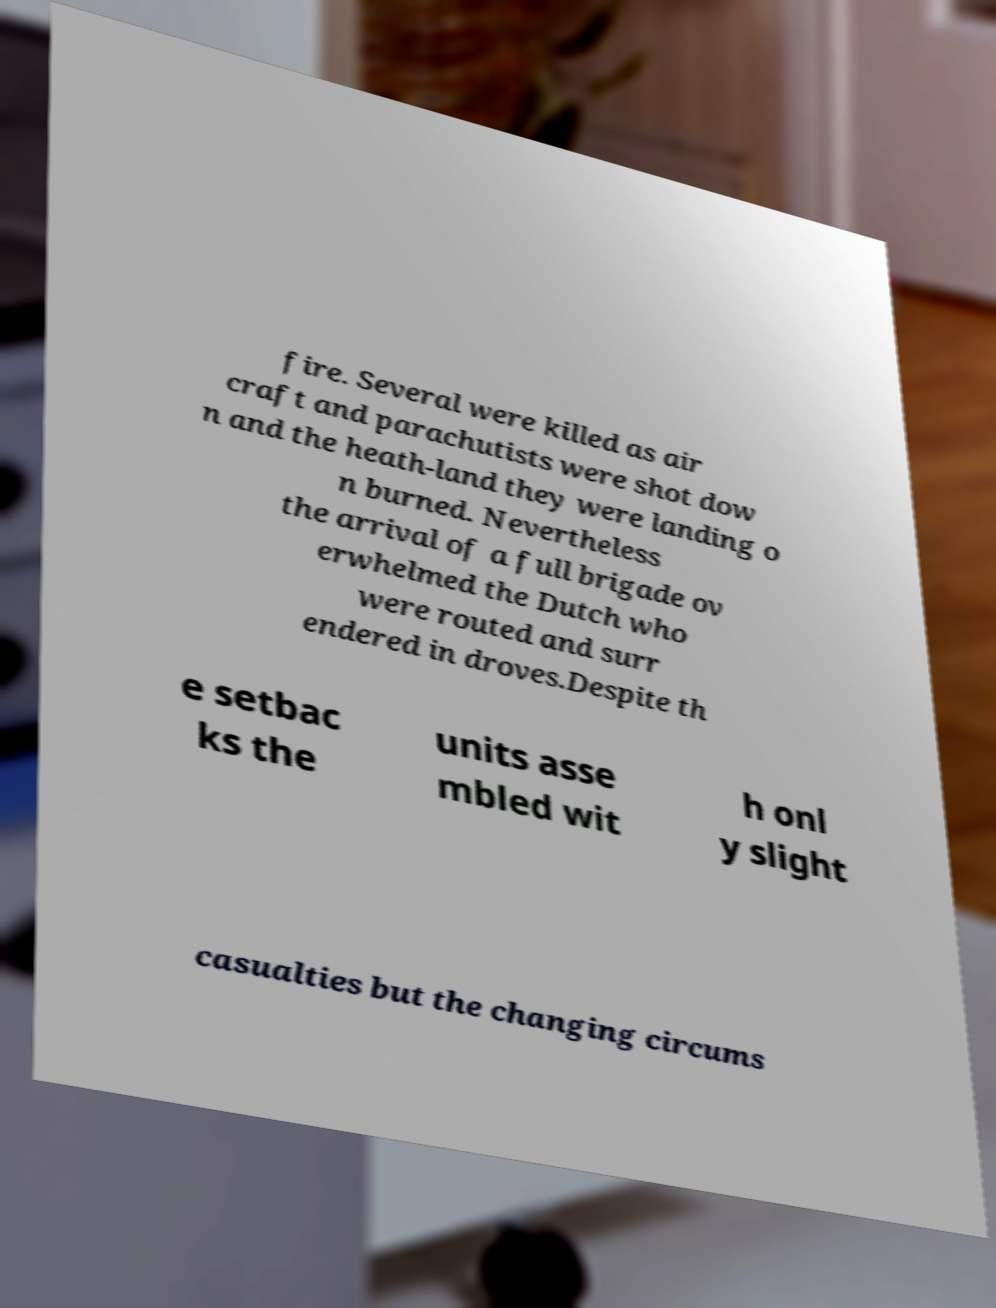There's text embedded in this image that I need extracted. Can you transcribe it verbatim? fire. Several were killed as air craft and parachutists were shot dow n and the heath-land they were landing o n burned. Nevertheless the arrival of a full brigade ov erwhelmed the Dutch who were routed and surr endered in droves.Despite th e setbac ks the units asse mbled wit h onl y slight casualties but the changing circums 